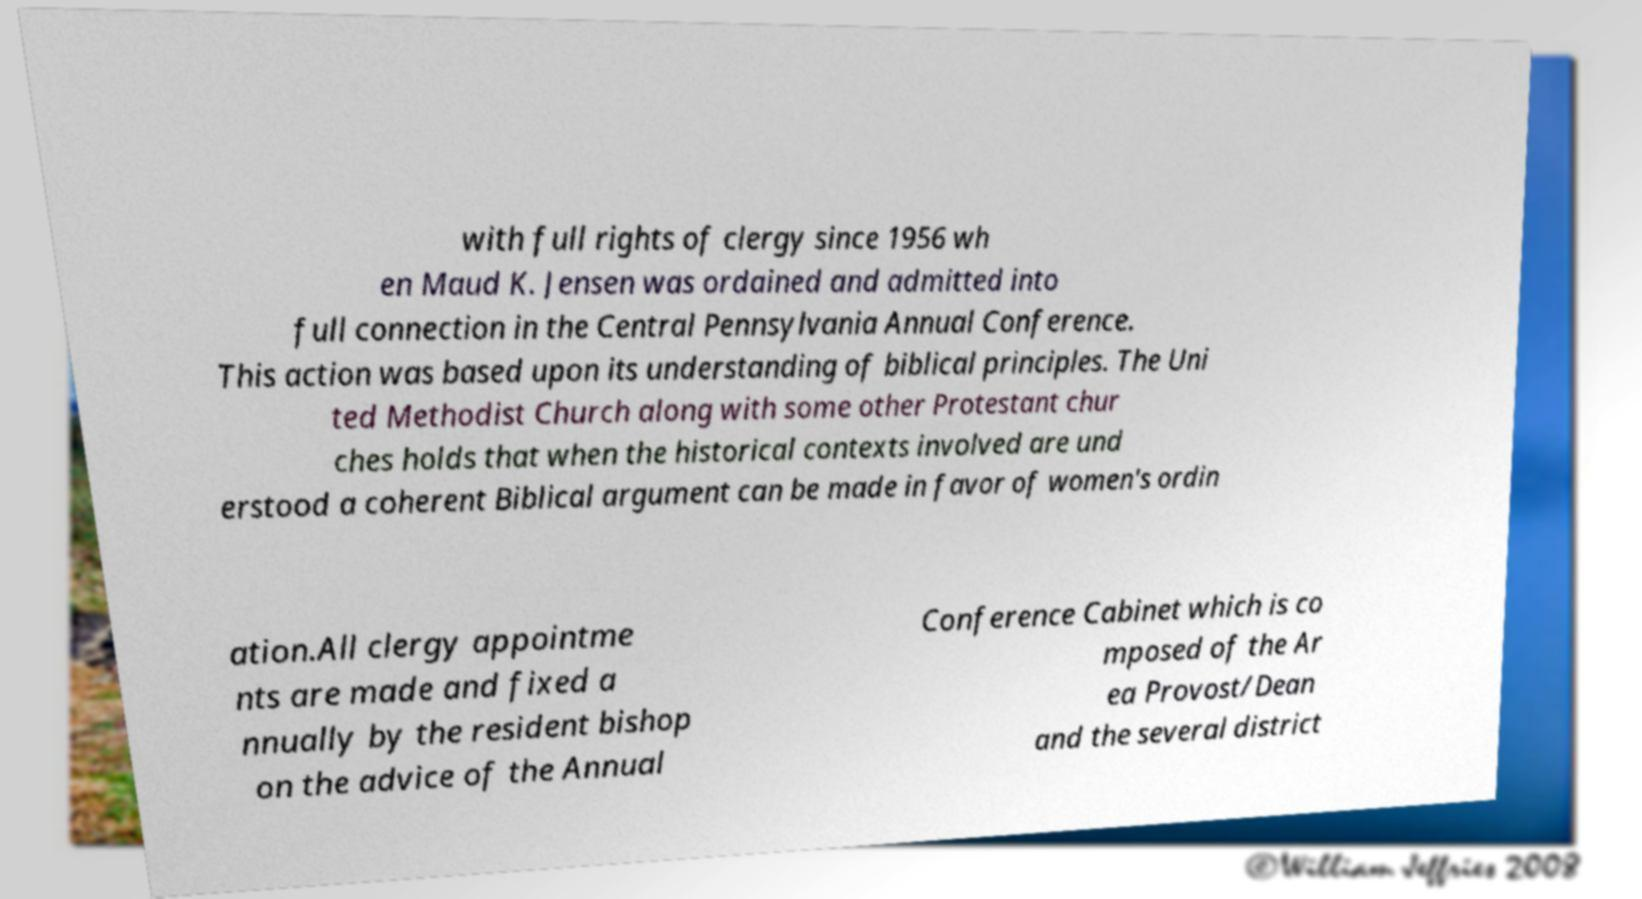Can you read and provide the text displayed in the image?This photo seems to have some interesting text. Can you extract and type it out for me? with full rights of clergy since 1956 wh en Maud K. Jensen was ordained and admitted into full connection in the Central Pennsylvania Annual Conference. This action was based upon its understanding of biblical principles. The Uni ted Methodist Church along with some other Protestant chur ches holds that when the historical contexts involved are und erstood a coherent Biblical argument can be made in favor of women's ordin ation.All clergy appointme nts are made and fixed a nnually by the resident bishop on the advice of the Annual Conference Cabinet which is co mposed of the Ar ea Provost/Dean and the several district 